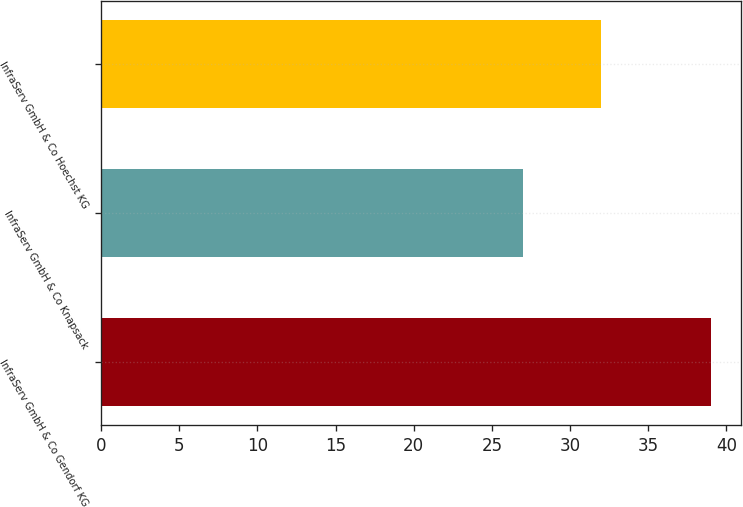<chart> <loc_0><loc_0><loc_500><loc_500><bar_chart><fcel>InfraServ GmbH & Co Gendorf KG<fcel>InfraServ GmbH & Co Knapsack<fcel>InfraServ GmbH & Co Hoechst KG<nl><fcel>39<fcel>27<fcel>32<nl></chart> 